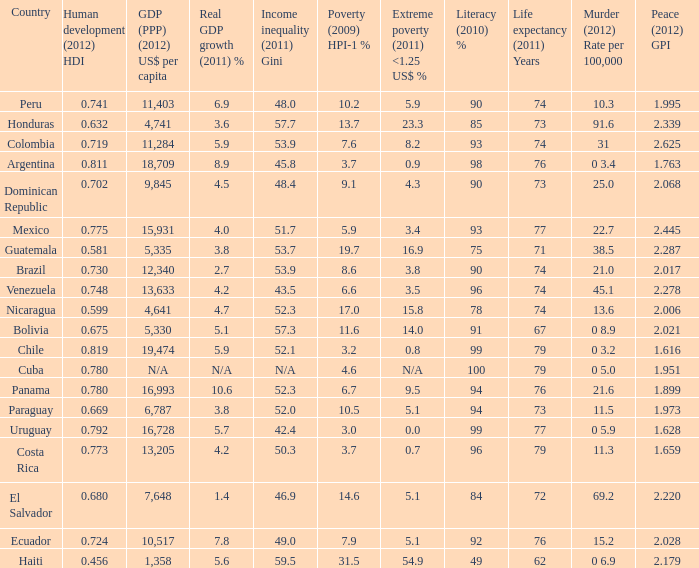What murder (2012) rate per 100,00 also has a 1.616 as the peace (2012) GPI? 0 3.2. 